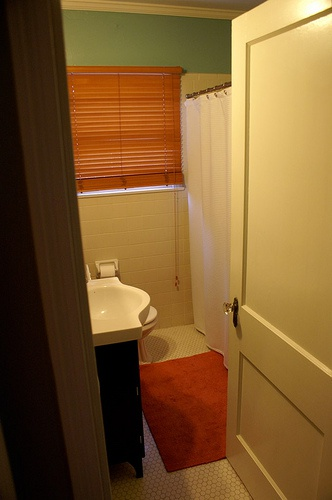Describe the objects in this image and their specific colors. I can see sink in black, tan, maroon, and olive tones and toilet in black, olive, maroon, and tan tones in this image. 